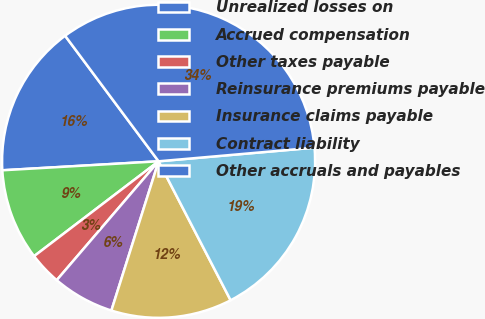Convert chart. <chart><loc_0><loc_0><loc_500><loc_500><pie_chart><fcel>Unrealized losses on<fcel>Accrued compensation<fcel>Other taxes payable<fcel>Reinsurance premiums payable<fcel>Insurance claims payable<fcel>Contract liability<fcel>Other accruals and payables<nl><fcel>15.73%<fcel>9.45%<fcel>3.36%<fcel>6.4%<fcel>12.49%<fcel>18.78%<fcel>33.8%<nl></chart> 